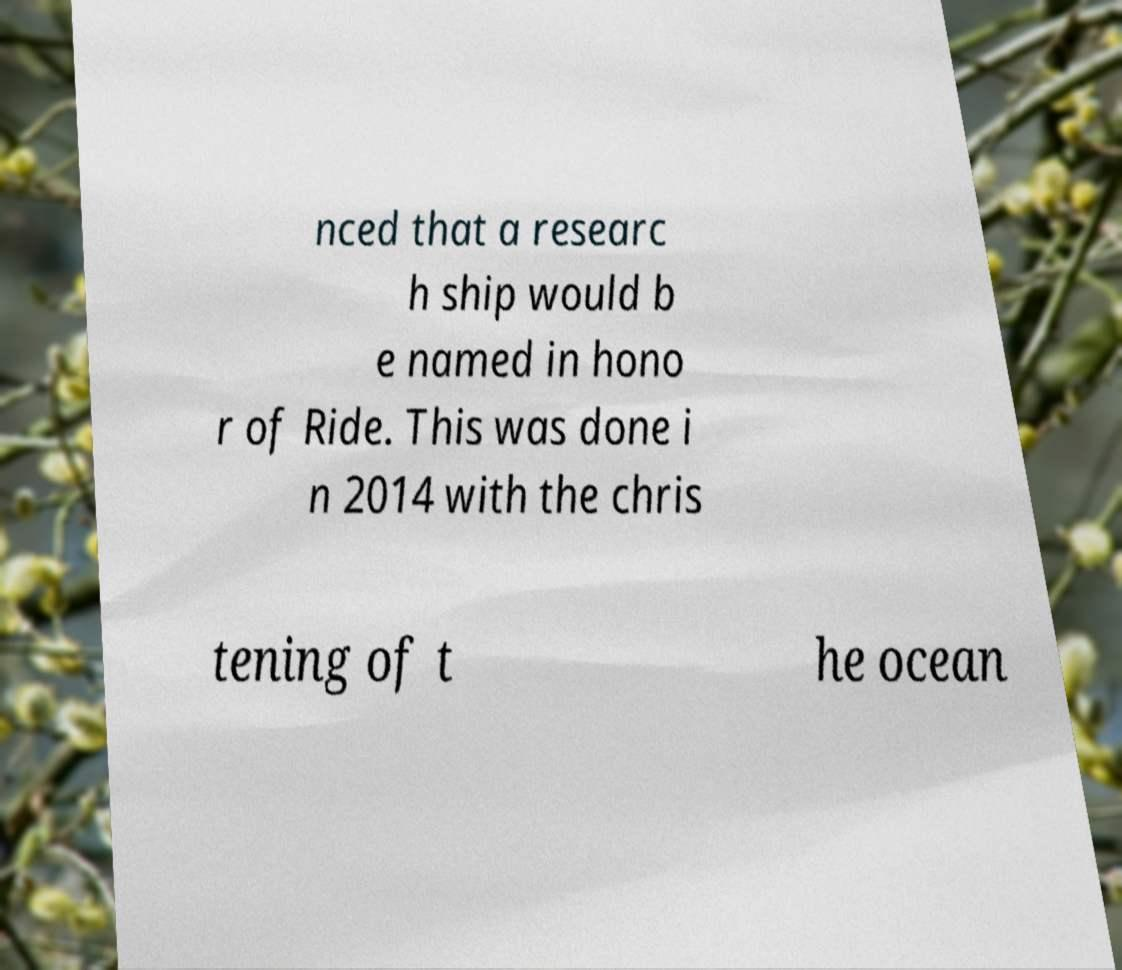What messages or text are displayed in this image? I need them in a readable, typed format. nced that a researc h ship would b e named in hono r of Ride. This was done i n 2014 with the chris tening of t he ocean 